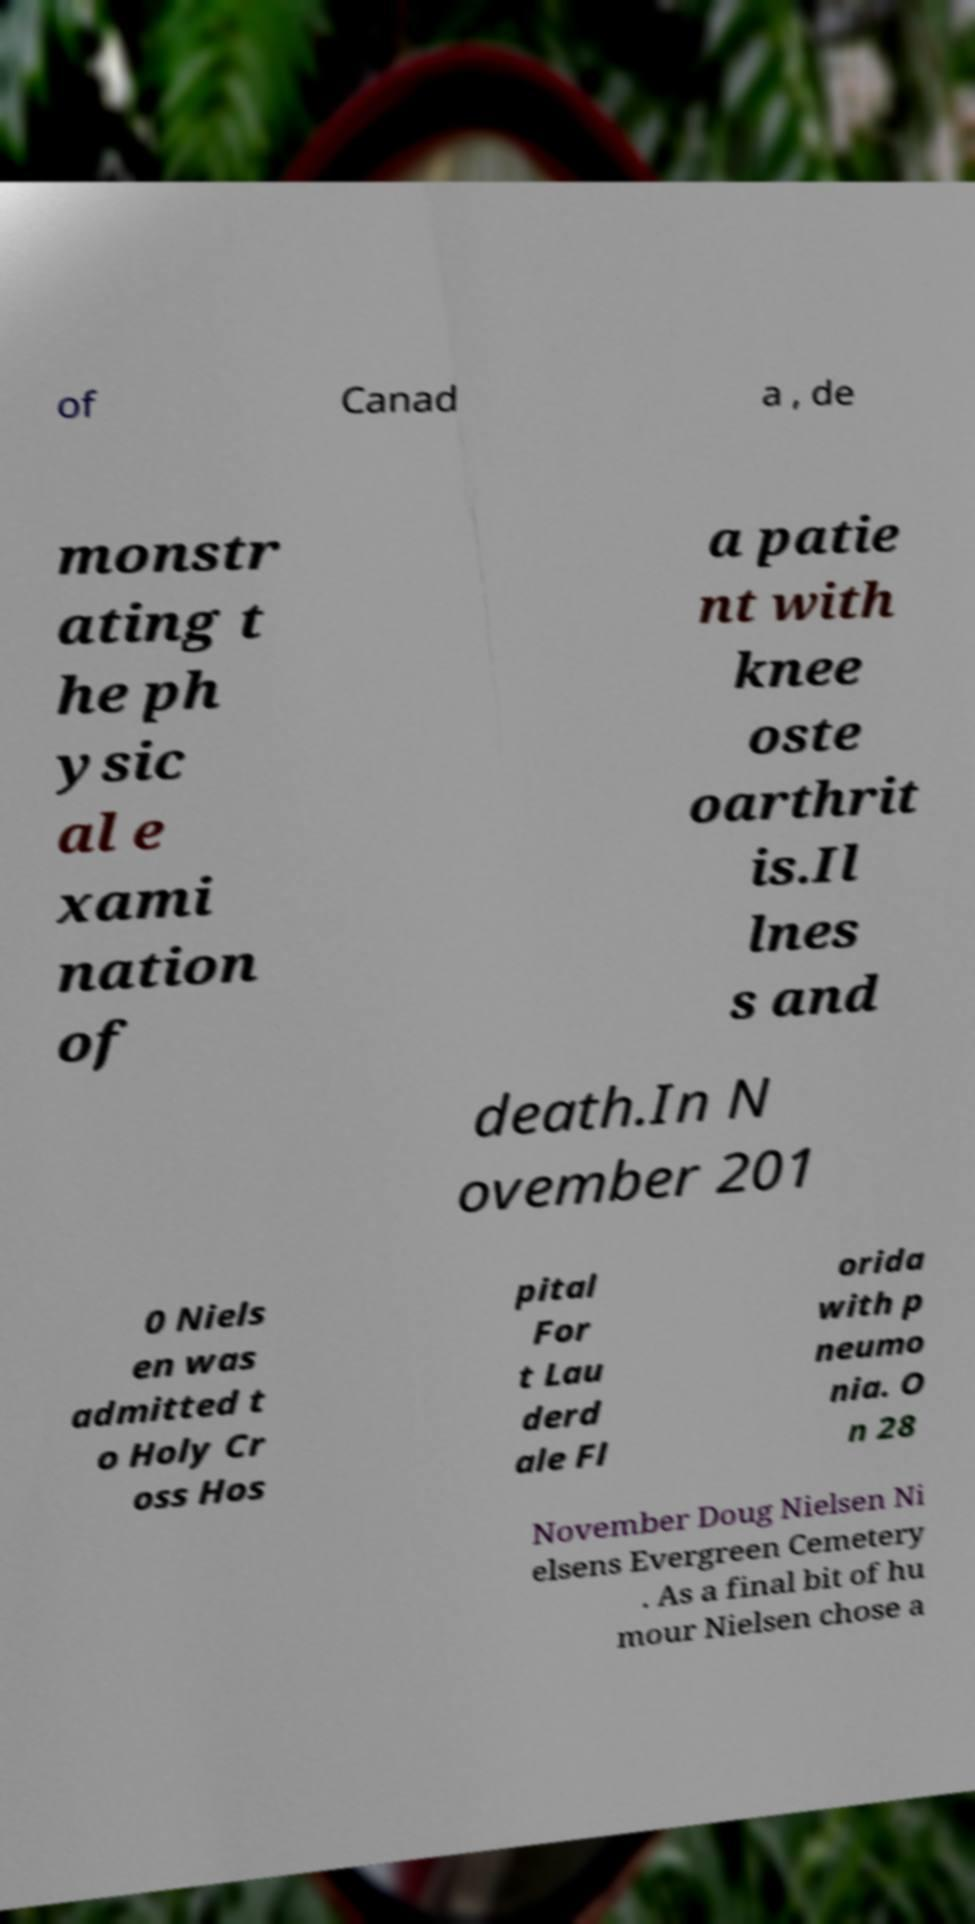There's text embedded in this image that I need extracted. Can you transcribe it verbatim? of Canad a , de monstr ating t he ph ysic al e xami nation of a patie nt with knee oste oarthrit is.Il lnes s and death.In N ovember 201 0 Niels en was admitted t o Holy Cr oss Hos pital For t Lau derd ale Fl orida with p neumo nia. O n 28 November Doug Nielsen Ni elsens Evergreen Cemetery . As a final bit of hu mour Nielsen chose a 